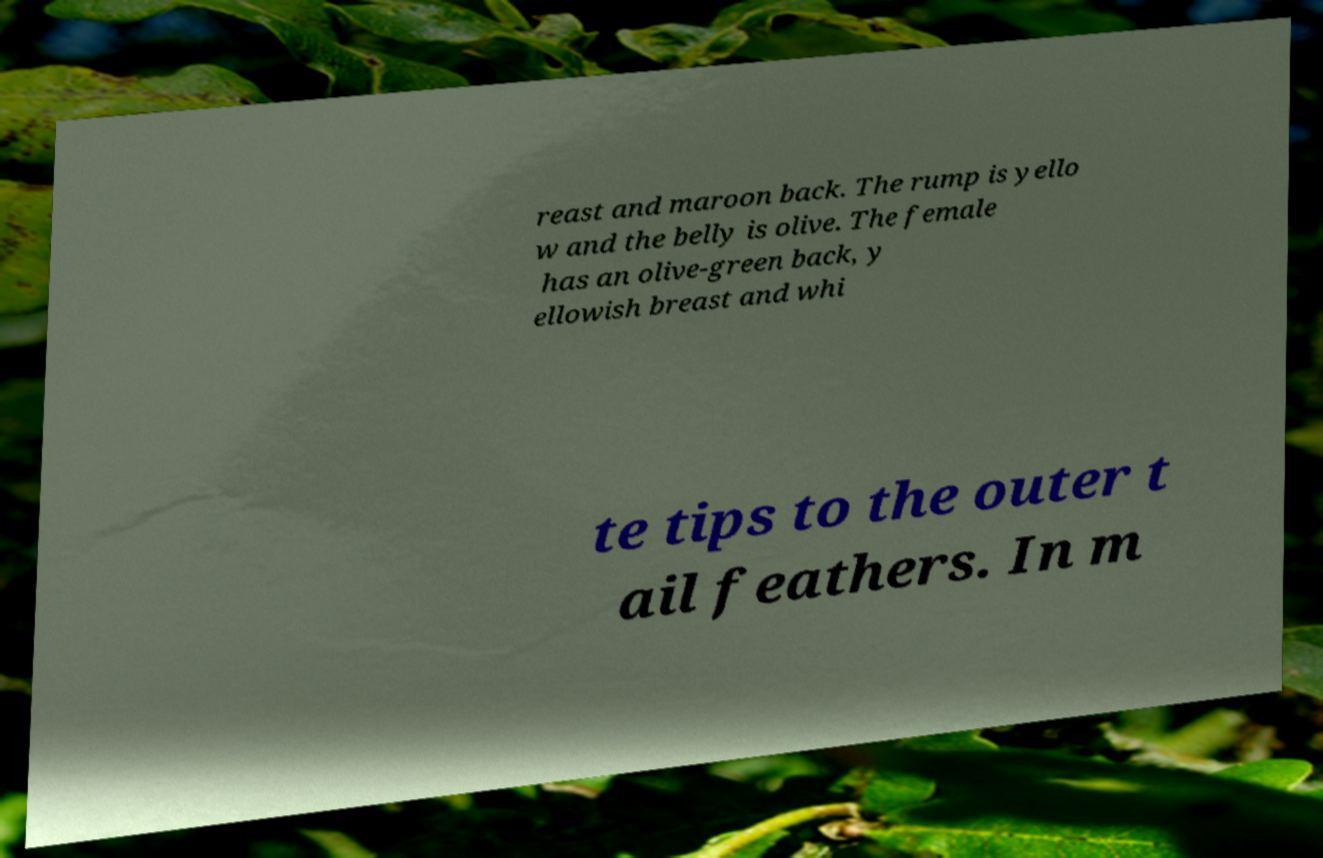Could you assist in decoding the text presented in this image and type it out clearly? reast and maroon back. The rump is yello w and the belly is olive. The female has an olive-green back, y ellowish breast and whi te tips to the outer t ail feathers. In m 